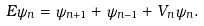<formula> <loc_0><loc_0><loc_500><loc_500>E \psi _ { n } = \psi _ { n + 1 } + \psi _ { n - 1 } + V _ { n } \psi _ { n } .</formula> 